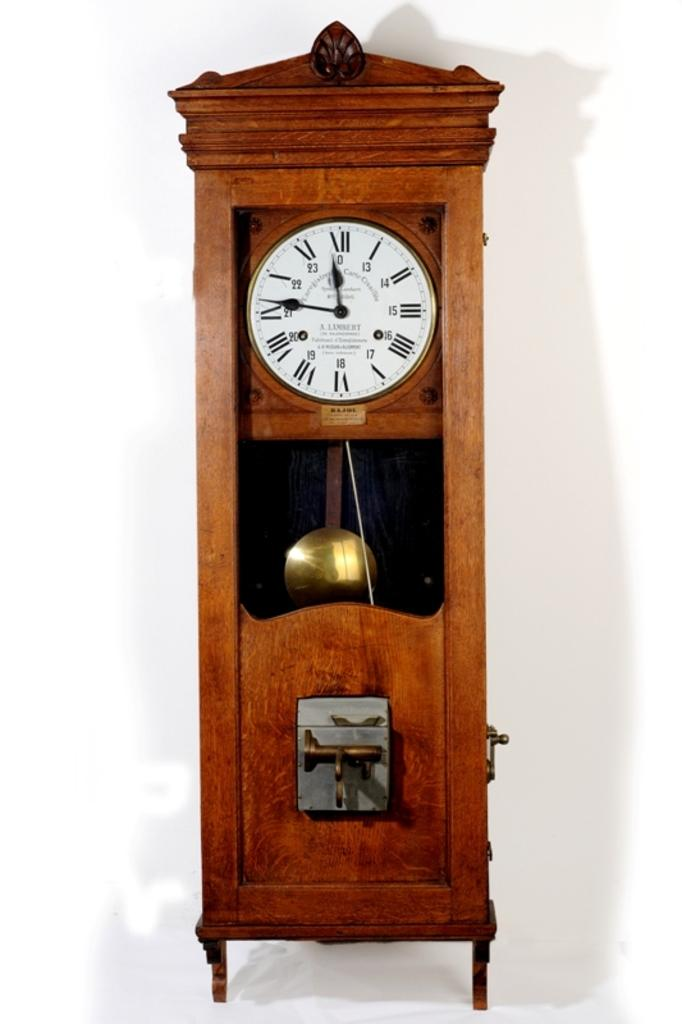<image>
Create a compact narrative representing the image presented. A wooden tall grandfather clock with roman numerals and a gold pendulum by the maker  Lennesky. 